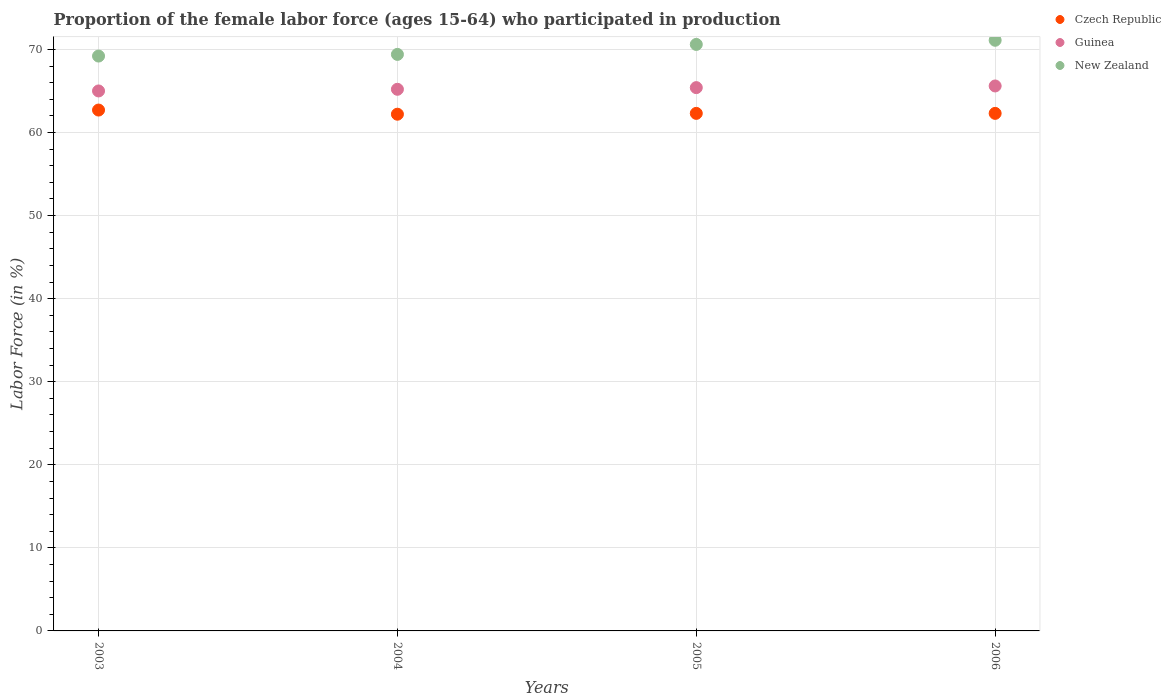How many different coloured dotlines are there?
Give a very brief answer. 3. What is the proportion of the female labor force who participated in production in Guinea in 2006?
Make the answer very short. 65.6. Across all years, what is the maximum proportion of the female labor force who participated in production in Guinea?
Your answer should be very brief. 65.6. Across all years, what is the minimum proportion of the female labor force who participated in production in Czech Republic?
Ensure brevity in your answer.  62.2. In which year was the proportion of the female labor force who participated in production in Guinea maximum?
Make the answer very short. 2006. What is the total proportion of the female labor force who participated in production in New Zealand in the graph?
Provide a succinct answer. 280.3. What is the difference between the proportion of the female labor force who participated in production in Guinea in 2003 and that in 2005?
Make the answer very short. -0.4. What is the difference between the proportion of the female labor force who participated in production in Guinea in 2004 and the proportion of the female labor force who participated in production in Czech Republic in 2003?
Your answer should be very brief. 2.5. What is the average proportion of the female labor force who participated in production in Guinea per year?
Your response must be concise. 65.3. In the year 2005, what is the difference between the proportion of the female labor force who participated in production in New Zealand and proportion of the female labor force who participated in production in Guinea?
Provide a succinct answer. 5.2. In how many years, is the proportion of the female labor force who participated in production in Guinea greater than 10 %?
Ensure brevity in your answer.  4. What is the ratio of the proportion of the female labor force who participated in production in New Zealand in 2003 to that in 2004?
Your answer should be compact. 1. Is the proportion of the female labor force who participated in production in New Zealand in 2005 less than that in 2006?
Make the answer very short. Yes. What is the difference between the highest and the second highest proportion of the female labor force who participated in production in Guinea?
Offer a terse response. 0.2. What is the difference between the highest and the lowest proportion of the female labor force who participated in production in New Zealand?
Your response must be concise. 1.9. In how many years, is the proportion of the female labor force who participated in production in New Zealand greater than the average proportion of the female labor force who participated in production in New Zealand taken over all years?
Provide a succinct answer. 2. Is it the case that in every year, the sum of the proportion of the female labor force who participated in production in New Zealand and proportion of the female labor force who participated in production in Guinea  is greater than the proportion of the female labor force who participated in production in Czech Republic?
Give a very brief answer. Yes. Is the proportion of the female labor force who participated in production in Czech Republic strictly greater than the proportion of the female labor force who participated in production in Guinea over the years?
Keep it short and to the point. No. Is the proportion of the female labor force who participated in production in Czech Republic strictly less than the proportion of the female labor force who participated in production in New Zealand over the years?
Your answer should be very brief. Yes. How many dotlines are there?
Offer a terse response. 3. What is the difference between two consecutive major ticks on the Y-axis?
Provide a short and direct response. 10. Are the values on the major ticks of Y-axis written in scientific E-notation?
Your answer should be very brief. No. How many legend labels are there?
Your answer should be compact. 3. How are the legend labels stacked?
Offer a terse response. Vertical. What is the title of the graph?
Make the answer very short. Proportion of the female labor force (ages 15-64) who participated in production. What is the label or title of the X-axis?
Your answer should be compact. Years. What is the Labor Force (in %) of Czech Republic in 2003?
Ensure brevity in your answer.  62.7. What is the Labor Force (in %) in New Zealand in 2003?
Make the answer very short. 69.2. What is the Labor Force (in %) in Czech Republic in 2004?
Your response must be concise. 62.2. What is the Labor Force (in %) of Guinea in 2004?
Offer a very short reply. 65.2. What is the Labor Force (in %) of New Zealand in 2004?
Offer a terse response. 69.4. What is the Labor Force (in %) of Czech Republic in 2005?
Provide a succinct answer. 62.3. What is the Labor Force (in %) of Guinea in 2005?
Offer a very short reply. 65.4. What is the Labor Force (in %) of New Zealand in 2005?
Your answer should be very brief. 70.6. What is the Labor Force (in %) of Czech Republic in 2006?
Make the answer very short. 62.3. What is the Labor Force (in %) of Guinea in 2006?
Provide a succinct answer. 65.6. What is the Labor Force (in %) in New Zealand in 2006?
Provide a succinct answer. 71.1. Across all years, what is the maximum Labor Force (in %) of Czech Republic?
Offer a terse response. 62.7. Across all years, what is the maximum Labor Force (in %) in Guinea?
Make the answer very short. 65.6. Across all years, what is the maximum Labor Force (in %) in New Zealand?
Offer a very short reply. 71.1. Across all years, what is the minimum Labor Force (in %) of Czech Republic?
Keep it short and to the point. 62.2. Across all years, what is the minimum Labor Force (in %) of Guinea?
Ensure brevity in your answer.  65. Across all years, what is the minimum Labor Force (in %) of New Zealand?
Ensure brevity in your answer.  69.2. What is the total Labor Force (in %) of Czech Republic in the graph?
Keep it short and to the point. 249.5. What is the total Labor Force (in %) in Guinea in the graph?
Your response must be concise. 261.2. What is the total Labor Force (in %) in New Zealand in the graph?
Give a very brief answer. 280.3. What is the difference between the Labor Force (in %) in Czech Republic in 2003 and that in 2004?
Your answer should be compact. 0.5. What is the difference between the Labor Force (in %) in Guinea in 2003 and that in 2004?
Keep it short and to the point. -0.2. What is the difference between the Labor Force (in %) in Guinea in 2003 and that in 2005?
Offer a very short reply. -0.4. What is the difference between the Labor Force (in %) of Guinea in 2004 and that in 2005?
Offer a very short reply. -0.2. What is the difference between the Labor Force (in %) of Czech Republic in 2004 and that in 2006?
Provide a succinct answer. -0.1. What is the difference between the Labor Force (in %) in Guinea in 2004 and that in 2006?
Make the answer very short. -0.4. What is the difference between the Labor Force (in %) in Guinea in 2005 and that in 2006?
Provide a succinct answer. -0.2. What is the difference between the Labor Force (in %) of New Zealand in 2005 and that in 2006?
Offer a terse response. -0.5. What is the difference between the Labor Force (in %) of Guinea in 2003 and the Labor Force (in %) of New Zealand in 2006?
Provide a succinct answer. -6.1. What is the difference between the Labor Force (in %) in Czech Republic in 2004 and the Labor Force (in %) in New Zealand in 2005?
Ensure brevity in your answer.  -8.4. What is the difference between the Labor Force (in %) of Czech Republic in 2004 and the Labor Force (in %) of New Zealand in 2006?
Offer a terse response. -8.9. What is the difference between the Labor Force (in %) of Guinea in 2004 and the Labor Force (in %) of New Zealand in 2006?
Ensure brevity in your answer.  -5.9. What is the average Labor Force (in %) of Czech Republic per year?
Offer a terse response. 62.38. What is the average Labor Force (in %) of Guinea per year?
Offer a terse response. 65.3. What is the average Labor Force (in %) of New Zealand per year?
Ensure brevity in your answer.  70.08. In the year 2003, what is the difference between the Labor Force (in %) of Czech Republic and Labor Force (in %) of New Zealand?
Offer a very short reply. -6.5. In the year 2004, what is the difference between the Labor Force (in %) in Czech Republic and Labor Force (in %) in New Zealand?
Provide a succinct answer. -7.2. In the year 2004, what is the difference between the Labor Force (in %) in Guinea and Labor Force (in %) in New Zealand?
Provide a short and direct response. -4.2. In the year 2005, what is the difference between the Labor Force (in %) of Czech Republic and Labor Force (in %) of Guinea?
Provide a succinct answer. -3.1. In the year 2005, what is the difference between the Labor Force (in %) of Guinea and Labor Force (in %) of New Zealand?
Give a very brief answer. -5.2. In the year 2006, what is the difference between the Labor Force (in %) of Czech Republic and Labor Force (in %) of Guinea?
Give a very brief answer. -3.3. In the year 2006, what is the difference between the Labor Force (in %) of Czech Republic and Labor Force (in %) of New Zealand?
Give a very brief answer. -8.8. In the year 2006, what is the difference between the Labor Force (in %) of Guinea and Labor Force (in %) of New Zealand?
Keep it short and to the point. -5.5. What is the ratio of the Labor Force (in %) of Czech Republic in 2003 to that in 2004?
Keep it short and to the point. 1.01. What is the ratio of the Labor Force (in %) of Guinea in 2003 to that in 2004?
Offer a terse response. 1. What is the ratio of the Labor Force (in %) in New Zealand in 2003 to that in 2004?
Offer a terse response. 1. What is the ratio of the Labor Force (in %) of Czech Republic in 2003 to that in 2005?
Provide a short and direct response. 1.01. What is the ratio of the Labor Force (in %) of New Zealand in 2003 to that in 2005?
Your answer should be very brief. 0.98. What is the ratio of the Labor Force (in %) of Czech Republic in 2003 to that in 2006?
Your response must be concise. 1.01. What is the ratio of the Labor Force (in %) of Guinea in 2003 to that in 2006?
Keep it short and to the point. 0.99. What is the ratio of the Labor Force (in %) of New Zealand in 2003 to that in 2006?
Ensure brevity in your answer.  0.97. What is the ratio of the Labor Force (in %) of Czech Republic in 2004 to that in 2005?
Ensure brevity in your answer.  1. What is the ratio of the Labor Force (in %) of Czech Republic in 2004 to that in 2006?
Your answer should be compact. 1. What is the ratio of the Labor Force (in %) of New Zealand in 2004 to that in 2006?
Your answer should be compact. 0.98. What is the ratio of the Labor Force (in %) in Czech Republic in 2005 to that in 2006?
Your response must be concise. 1. What is the ratio of the Labor Force (in %) in New Zealand in 2005 to that in 2006?
Provide a succinct answer. 0.99. What is the difference between the highest and the second highest Labor Force (in %) in Czech Republic?
Your response must be concise. 0.4. What is the difference between the highest and the second highest Labor Force (in %) in Guinea?
Keep it short and to the point. 0.2. What is the difference between the highest and the second highest Labor Force (in %) in New Zealand?
Ensure brevity in your answer.  0.5. What is the difference between the highest and the lowest Labor Force (in %) in Guinea?
Ensure brevity in your answer.  0.6. 